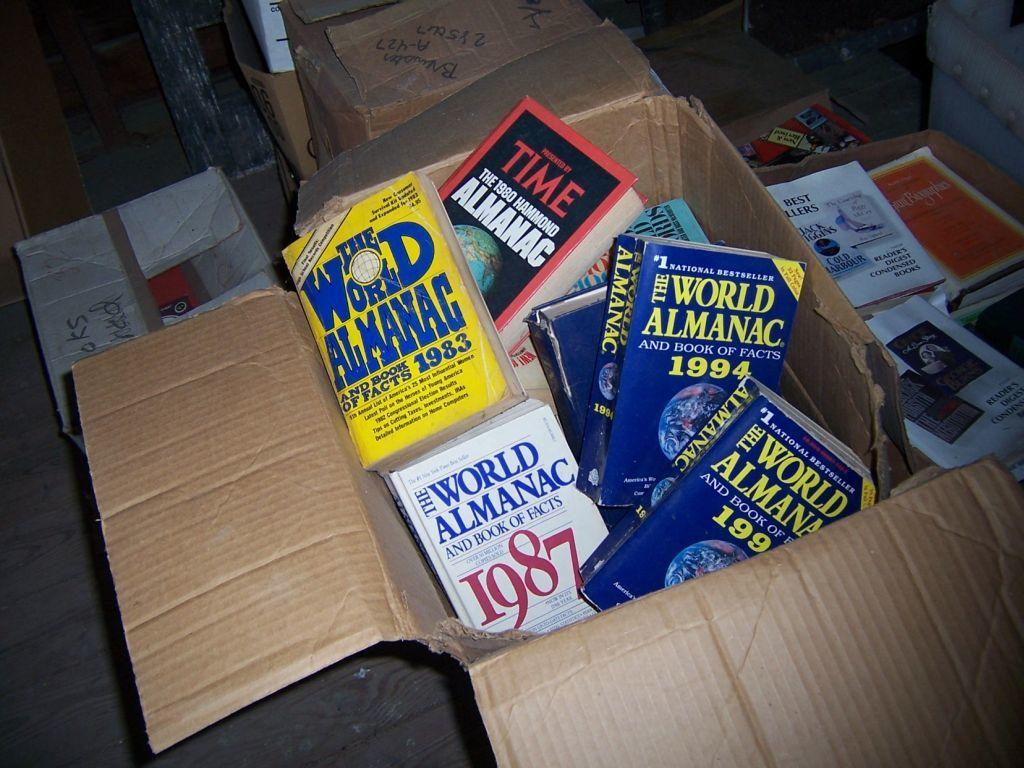<image>
Relay a brief, clear account of the picture shown. A carboard box filled with World Alamacs from various dates. 